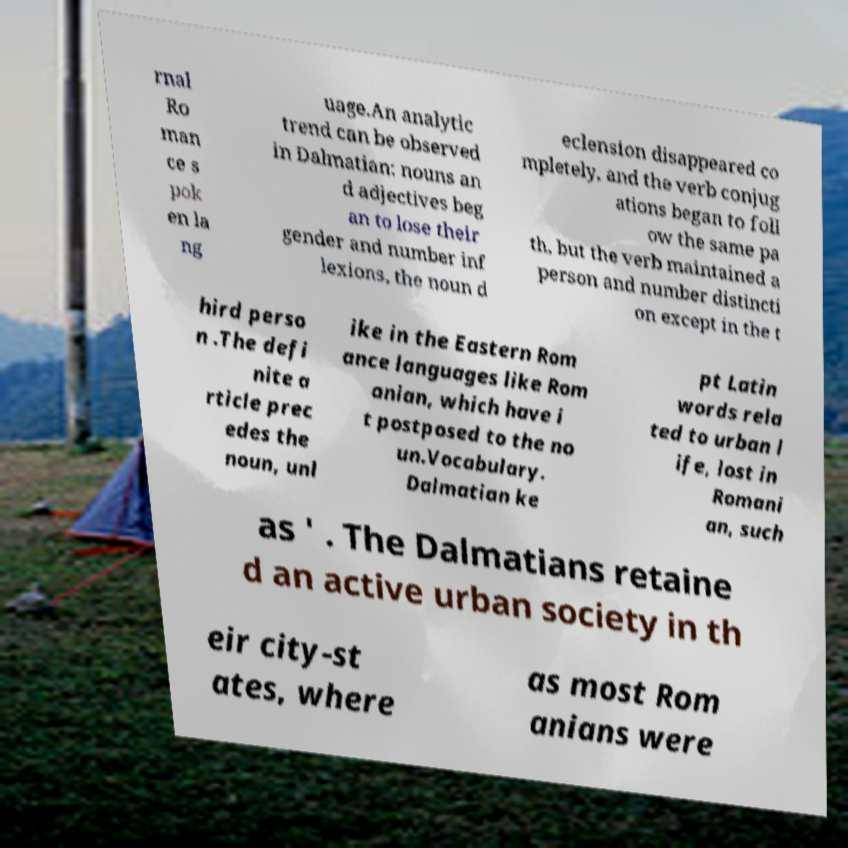I need the written content from this picture converted into text. Can you do that? rnal Ro man ce s pok en la ng uage.An analytic trend can be observed in Dalmatian: nouns an d adjectives beg an to lose their gender and number inf lexions, the noun d eclension disappeared co mpletely, and the verb conjug ations began to foll ow the same pa th, but the verb maintained a person and number distincti on except in the t hird perso n .The defi nite a rticle prec edes the noun, unl ike in the Eastern Rom ance languages like Rom anian, which have i t postposed to the no un.Vocabulary. Dalmatian ke pt Latin words rela ted to urban l ife, lost in Romani an, such as ' . The Dalmatians retaine d an active urban society in th eir city-st ates, where as most Rom anians were 